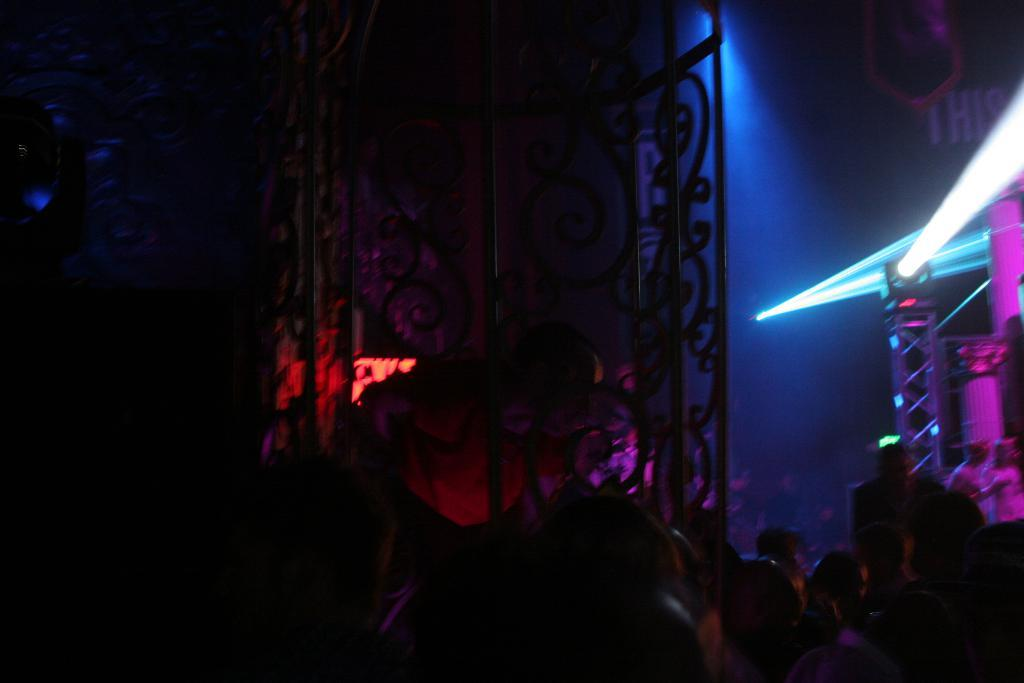What is the overall lighting condition in the image? The image is dark. Where are the persons located in the image? The persons are at the bottom of the image. What can be seen in the background of the image? There are lights and poles in the background of the image. What is written on the platform in the background of the image? There is a text written on a platform in the background of the image. How many cows are present in the image? There are no cows present in the image. What type of kittens can be seen playing with the text on the platform? There are no kittens present in the image, and the text on the platform is not associated with any playful activity. 